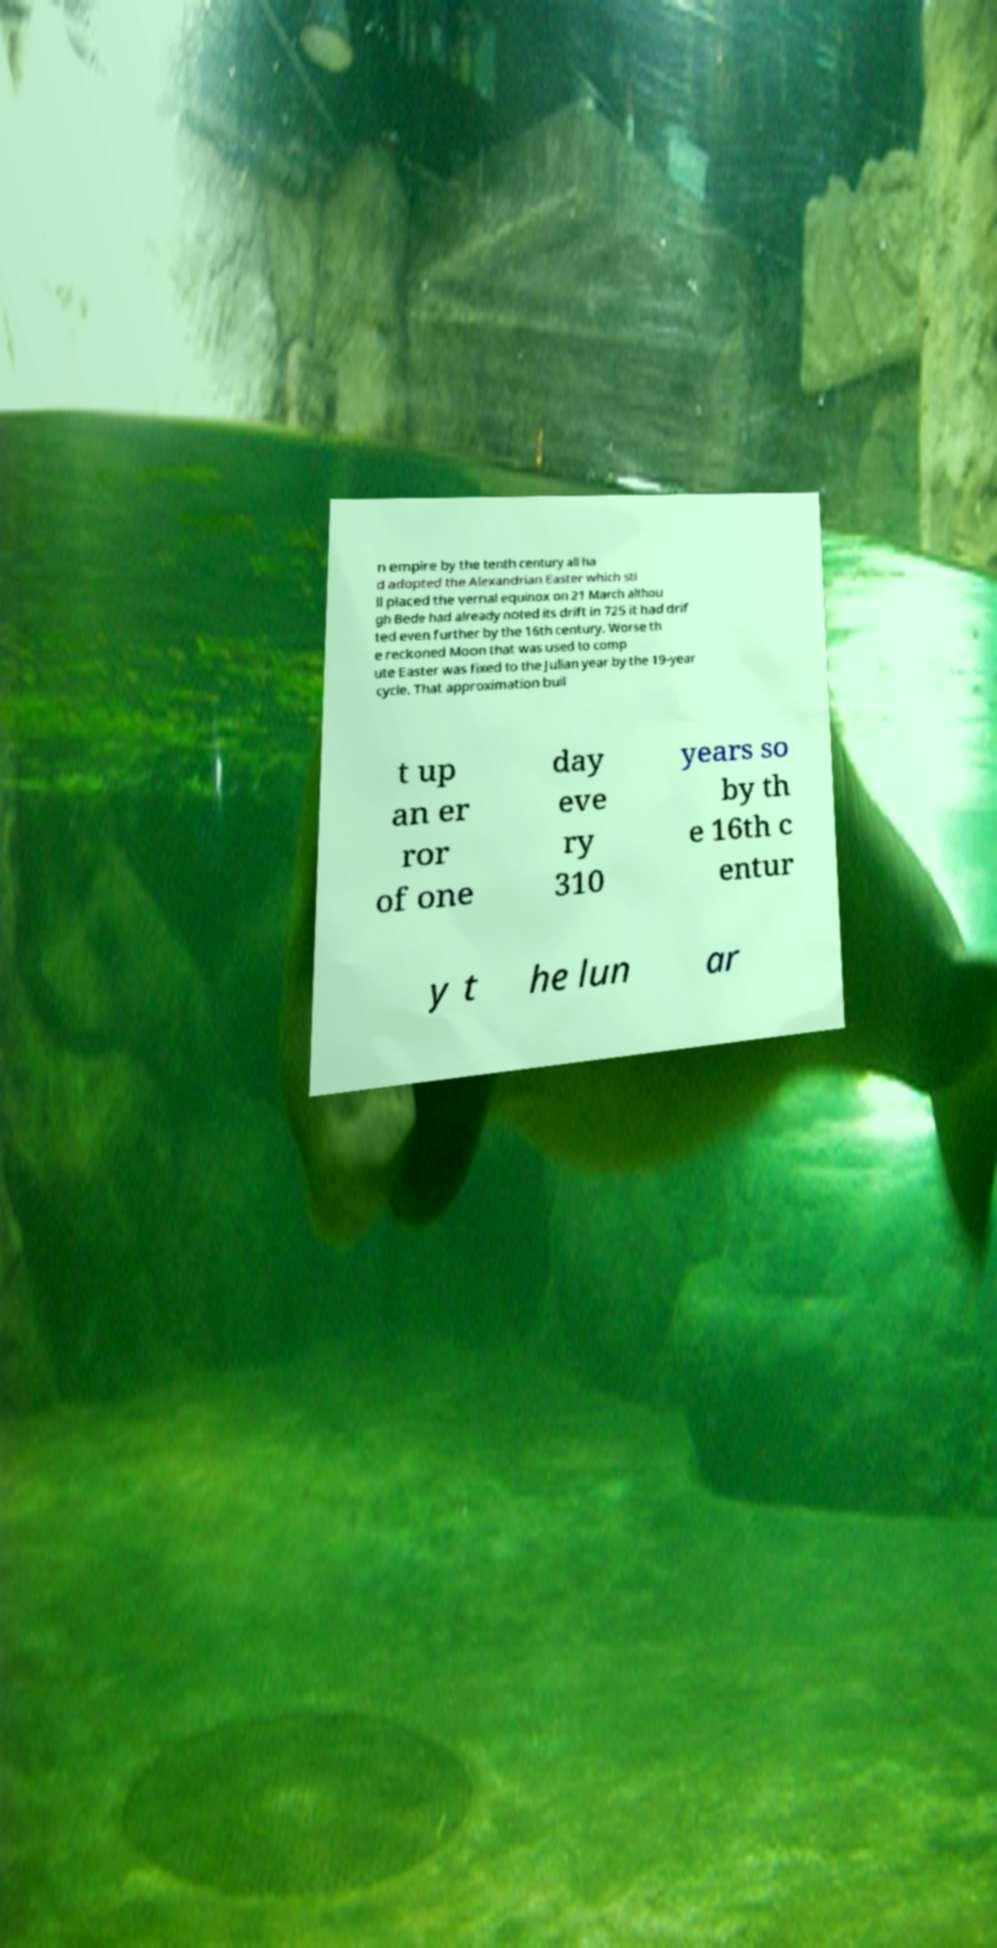What messages or text are displayed in this image? I need them in a readable, typed format. n empire by the tenth century all ha d adopted the Alexandrian Easter which sti ll placed the vernal equinox on 21 March althou gh Bede had already noted its drift in 725 it had drif ted even further by the 16th century. Worse th e reckoned Moon that was used to comp ute Easter was fixed to the Julian year by the 19-year cycle. That approximation buil t up an er ror of one day eve ry 310 years so by th e 16th c entur y t he lun ar 